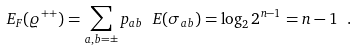Convert formula to latex. <formula><loc_0><loc_0><loc_500><loc_500>E _ { F } ( \varrho ^ { + + } ) = \sum _ { a , b = \pm } p _ { a b } \ E ( \sigma _ { a b } ) = \log _ { 2 } 2 ^ { n - 1 } = n - 1 \ .</formula> 